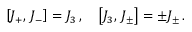<formula> <loc_0><loc_0><loc_500><loc_500>\left [ J _ { + } , \, J _ { - } \right ] = J _ { 3 } \, , \quad \left [ J _ { 3 } , \, J _ { \pm } \right ] = \pm J _ { \pm } \, .</formula> 